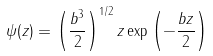<formula> <loc_0><loc_0><loc_500><loc_500>\psi ( z ) = \left ( { \frac { b ^ { 3 } } { 2 } } \right ) ^ { 1 / 2 } z \exp \left ( - { \frac { b z } { 2 } } \right )</formula> 